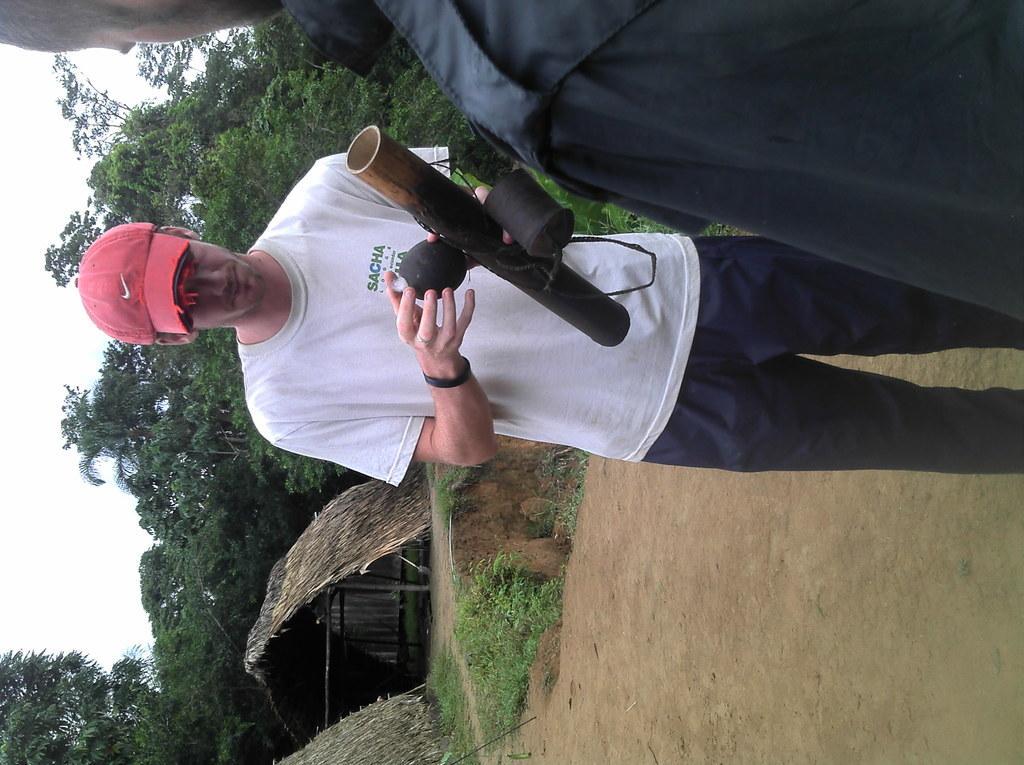In one or two sentences, can you explain what this image depicts? Here we can see two persons and he is holding an object. In the background we can see huts, grass, trees, and sky. 